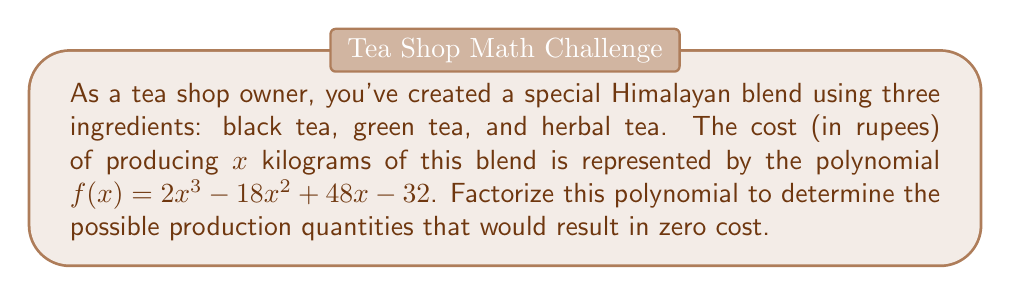What is the answer to this math problem? To factorize the polynomial $f(x) = 2x^3 - 18x^2 + 48x - 32$, we'll follow these steps:

1) First, let's check if there's a common factor:
   $2x^3 - 18x^2 + 48x - 32 = 2(x^3 - 9x^2 + 24x - 16)$

2) Now, we'll focus on factorizing $x^3 - 9x^2 + 24x - 16$

3) Let's try to guess one factor. Since the constant term is -16, possible factors are ±1, ±2, ±4, ±8, ±16. 
   After trying, we find that (x - 2) is a factor.

4) Divide $x^3 - 9x^2 + 24x - 16$ by (x - 2):
   $x^3 - 9x^2 + 24x - 16 = (x - 2)(x^2 - 7x + 8)$

5) Now we need to factorize $x^2 - 7x + 8$:
   $x^2 - 7x + 8 = (x - 4)(x - 3)$

6) Putting it all together:
   $f(x) = 2x^3 - 18x^2 + 48x - 32$
   $= 2(x^3 - 9x^2 + 24x - 16)$
   $= 2(x - 2)(x^2 - 7x + 8)$
   $= 2(x - 2)(x - 4)(x - 3)$

Therefore, the polynomial is fully factorized as $2(x - 2)(x - 4)(x - 3)$.
Answer: $2(x - 2)(x - 4)(x - 3)$ 